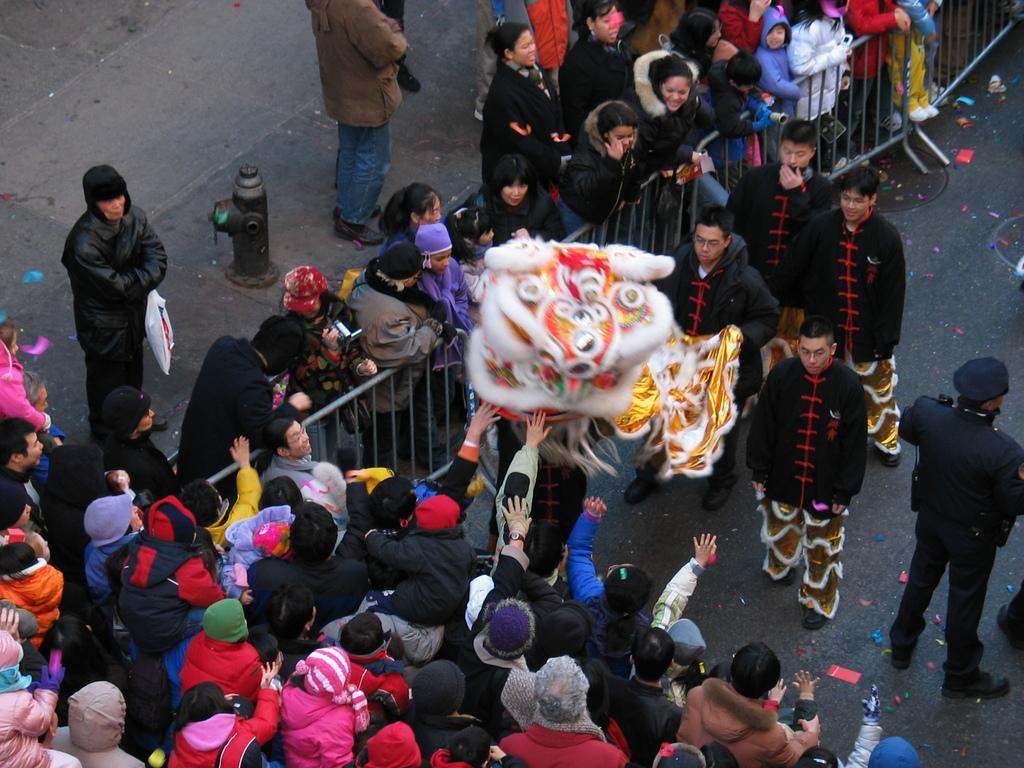What is happening in the image? There are people standing in the image. What are some of the people doing in the image? Some people are holding an object. What can be seen in the middle of the image? There is a fence in the center of the image. What type of feather can be seen on the cannon in the image? There is no cannon or feather present in the image. What scientific principle is being demonstrated in the image? The image does not depict a scientific principle being demonstrated. 